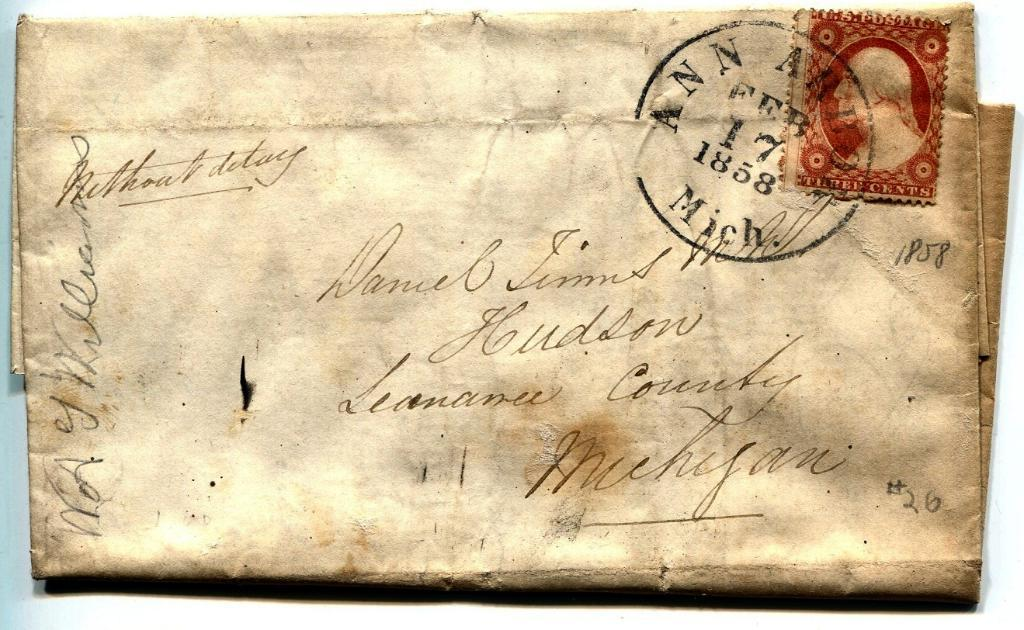<image>
Render a clear and concise summary of the photo. A worn envelope has a Feb 17 1858 delivery stamp. 